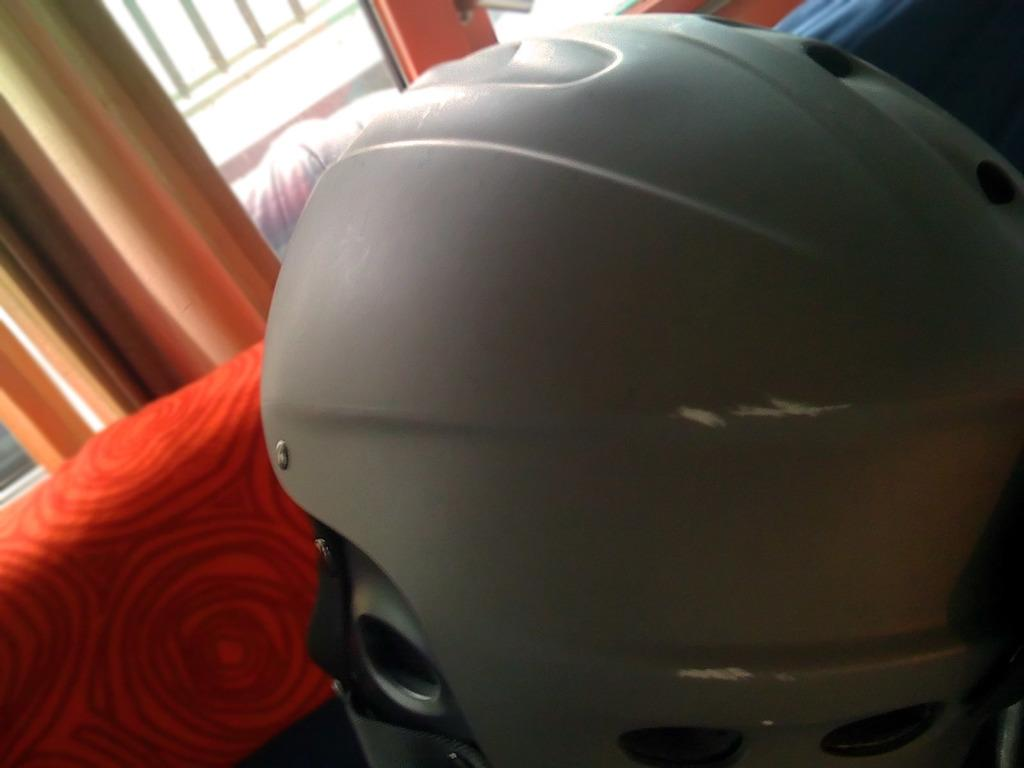What is the main object in the foreground of the image? There is a helmet in the foreground of the image. What is the color of the object behind the helmet? The object behind the helmet appears to be red. What might the red object be? The red object appears to be a window glass. What type of coat is being worn by the person in the image? There is no person visible in the image, and therefore no coat can be observed. 